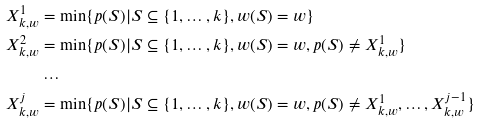<formula> <loc_0><loc_0><loc_500><loc_500>X ^ { 1 } _ { k , w } & = \min \{ p ( S ) | S \subseteq \{ 1 , \dots , k \} , w ( S ) = w \} \\ X ^ { 2 } _ { k , w } & = \min \{ p ( S ) | S \subseteq \{ 1 , \dots , k \} , w ( S ) = w , p ( S ) \neq X ^ { 1 } _ { k , w } \} \\ & \dots \\ X ^ { j } _ { k , w } & = \min \{ p ( S ) | S \subseteq \{ 1 , \dots , k \} , w ( S ) = w , p ( S ) \neq X ^ { 1 } _ { k , w } , \dots , X ^ { j - 1 } _ { k , w } \}</formula> 